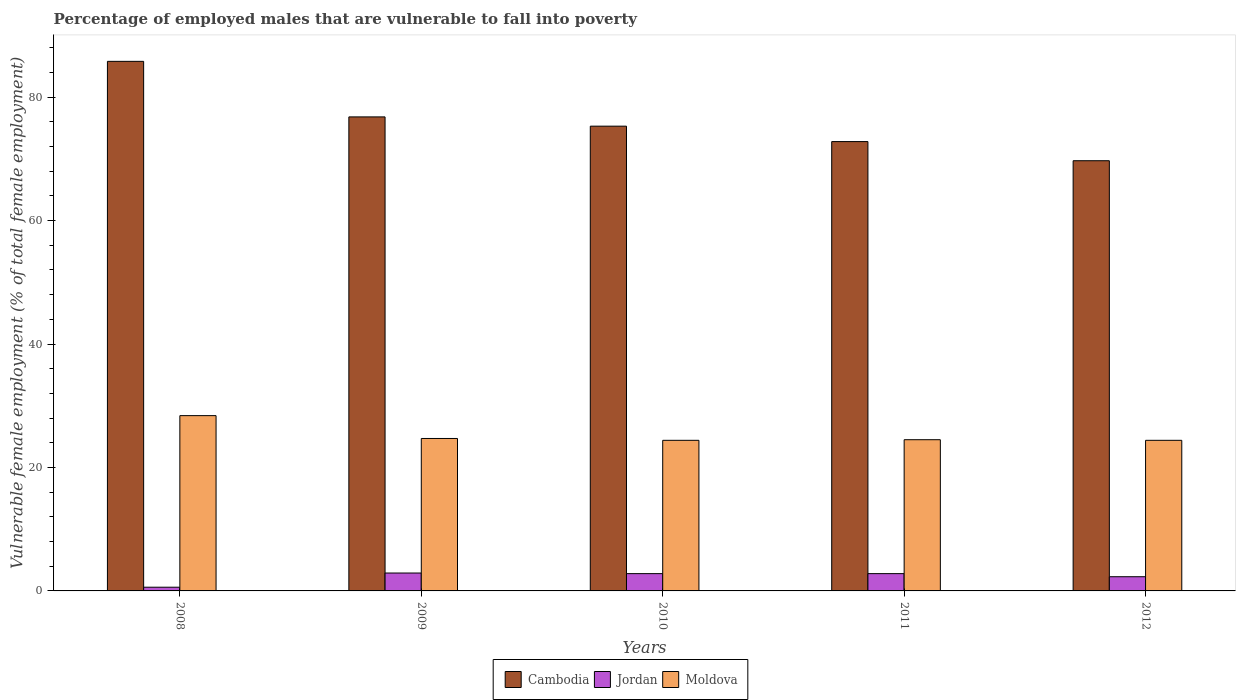How many groups of bars are there?
Offer a very short reply. 5. Are the number of bars per tick equal to the number of legend labels?
Provide a succinct answer. Yes. How many bars are there on the 5th tick from the right?
Offer a very short reply. 3. What is the label of the 3rd group of bars from the left?
Provide a succinct answer. 2010. Across all years, what is the maximum percentage of employed males who are vulnerable to fall into poverty in Moldova?
Your answer should be compact. 28.4. Across all years, what is the minimum percentage of employed males who are vulnerable to fall into poverty in Cambodia?
Your answer should be compact. 69.7. In which year was the percentage of employed males who are vulnerable to fall into poverty in Jordan maximum?
Ensure brevity in your answer.  2009. In which year was the percentage of employed males who are vulnerable to fall into poverty in Jordan minimum?
Offer a very short reply. 2008. What is the total percentage of employed males who are vulnerable to fall into poverty in Moldova in the graph?
Your response must be concise. 126.4. What is the difference between the percentage of employed males who are vulnerable to fall into poverty in Moldova in 2008 and the percentage of employed males who are vulnerable to fall into poverty in Jordan in 2012?
Give a very brief answer. 26.1. What is the average percentage of employed males who are vulnerable to fall into poverty in Cambodia per year?
Give a very brief answer. 76.08. In the year 2009, what is the difference between the percentage of employed males who are vulnerable to fall into poverty in Cambodia and percentage of employed males who are vulnerable to fall into poverty in Jordan?
Make the answer very short. 73.9. In how many years, is the percentage of employed males who are vulnerable to fall into poverty in Moldova greater than 32 %?
Make the answer very short. 0. What is the ratio of the percentage of employed males who are vulnerable to fall into poverty in Cambodia in 2009 to that in 2012?
Your response must be concise. 1.1. What is the difference between the highest and the second highest percentage of employed males who are vulnerable to fall into poverty in Jordan?
Keep it short and to the point. 0.1. What is the difference between the highest and the lowest percentage of employed males who are vulnerable to fall into poverty in Cambodia?
Your response must be concise. 16.1. In how many years, is the percentage of employed males who are vulnerable to fall into poverty in Cambodia greater than the average percentage of employed males who are vulnerable to fall into poverty in Cambodia taken over all years?
Your answer should be compact. 2. What does the 3rd bar from the left in 2008 represents?
Your answer should be compact. Moldova. What does the 3rd bar from the right in 2012 represents?
Offer a terse response. Cambodia. Are all the bars in the graph horizontal?
Make the answer very short. No. Are the values on the major ticks of Y-axis written in scientific E-notation?
Your response must be concise. No. Does the graph contain grids?
Make the answer very short. No. How many legend labels are there?
Provide a succinct answer. 3. What is the title of the graph?
Make the answer very short. Percentage of employed males that are vulnerable to fall into poverty. Does "St. Vincent and the Grenadines" appear as one of the legend labels in the graph?
Offer a very short reply. No. What is the label or title of the X-axis?
Ensure brevity in your answer.  Years. What is the label or title of the Y-axis?
Provide a short and direct response. Vulnerable female employment (% of total female employment). What is the Vulnerable female employment (% of total female employment) in Cambodia in 2008?
Give a very brief answer. 85.8. What is the Vulnerable female employment (% of total female employment) in Jordan in 2008?
Provide a short and direct response. 0.6. What is the Vulnerable female employment (% of total female employment) of Moldova in 2008?
Ensure brevity in your answer.  28.4. What is the Vulnerable female employment (% of total female employment) in Cambodia in 2009?
Give a very brief answer. 76.8. What is the Vulnerable female employment (% of total female employment) in Jordan in 2009?
Provide a succinct answer. 2.9. What is the Vulnerable female employment (% of total female employment) in Moldova in 2009?
Give a very brief answer. 24.7. What is the Vulnerable female employment (% of total female employment) in Cambodia in 2010?
Provide a succinct answer. 75.3. What is the Vulnerable female employment (% of total female employment) in Jordan in 2010?
Ensure brevity in your answer.  2.8. What is the Vulnerable female employment (% of total female employment) of Moldova in 2010?
Offer a very short reply. 24.4. What is the Vulnerable female employment (% of total female employment) in Cambodia in 2011?
Offer a very short reply. 72.8. What is the Vulnerable female employment (% of total female employment) of Jordan in 2011?
Your answer should be compact. 2.8. What is the Vulnerable female employment (% of total female employment) of Moldova in 2011?
Offer a terse response. 24.5. What is the Vulnerable female employment (% of total female employment) of Cambodia in 2012?
Give a very brief answer. 69.7. What is the Vulnerable female employment (% of total female employment) in Jordan in 2012?
Give a very brief answer. 2.3. What is the Vulnerable female employment (% of total female employment) of Moldova in 2012?
Your response must be concise. 24.4. Across all years, what is the maximum Vulnerable female employment (% of total female employment) of Cambodia?
Your answer should be very brief. 85.8. Across all years, what is the maximum Vulnerable female employment (% of total female employment) of Jordan?
Provide a succinct answer. 2.9. Across all years, what is the maximum Vulnerable female employment (% of total female employment) in Moldova?
Offer a terse response. 28.4. Across all years, what is the minimum Vulnerable female employment (% of total female employment) of Cambodia?
Ensure brevity in your answer.  69.7. Across all years, what is the minimum Vulnerable female employment (% of total female employment) of Jordan?
Your answer should be compact. 0.6. Across all years, what is the minimum Vulnerable female employment (% of total female employment) of Moldova?
Ensure brevity in your answer.  24.4. What is the total Vulnerable female employment (% of total female employment) of Cambodia in the graph?
Give a very brief answer. 380.4. What is the total Vulnerable female employment (% of total female employment) of Jordan in the graph?
Your answer should be very brief. 11.4. What is the total Vulnerable female employment (% of total female employment) of Moldova in the graph?
Make the answer very short. 126.4. What is the difference between the Vulnerable female employment (% of total female employment) in Cambodia in 2008 and that in 2010?
Offer a terse response. 10.5. What is the difference between the Vulnerable female employment (% of total female employment) in Moldova in 2008 and that in 2010?
Your answer should be very brief. 4. What is the difference between the Vulnerable female employment (% of total female employment) in Cambodia in 2008 and that in 2011?
Offer a very short reply. 13. What is the difference between the Vulnerable female employment (% of total female employment) in Moldova in 2008 and that in 2011?
Your answer should be very brief. 3.9. What is the difference between the Vulnerable female employment (% of total female employment) of Cambodia in 2008 and that in 2012?
Provide a short and direct response. 16.1. What is the difference between the Vulnerable female employment (% of total female employment) of Moldova in 2008 and that in 2012?
Keep it short and to the point. 4. What is the difference between the Vulnerable female employment (% of total female employment) of Cambodia in 2009 and that in 2010?
Your answer should be compact. 1.5. What is the difference between the Vulnerable female employment (% of total female employment) in Moldova in 2009 and that in 2010?
Your answer should be very brief. 0.3. What is the difference between the Vulnerable female employment (% of total female employment) of Cambodia in 2009 and that in 2011?
Provide a succinct answer. 4. What is the difference between the Vulnerable female employment (% of total female employment) of Jordan in 2009 and that in 2011?
Give a very brief answer. 0.1. What is the difference between the Vulnerable female employment (% of total female employment) in Cambodia in 2009 and that in 2012?
Keep it short and to the point. 7.1. What is the difference between the Vulnerable female employment (% of total female employment) in Jordan in 2009 and that in 2012?
Keep it short and to the point. 0.6. What is the difference between the Vulnerable female employment (% of total female employment) of Moldova in 2009 and that in 2012?
Your answer should be very brief. 0.3. What is the difference between the Vulnerable female employment (% of total female employment) in Jordan in 2010 and that in 2011?
Provide a succinct answer. 0. What is the difference between the Vulnerable female employment (% of total female employment) in Moldova in 2010 and that in 2011?
Provide a succinct answer. -0.1. What is the difference between the Vulnerable female employment (% of total female employment) in Moldova in 2010 and that in 2012?
Provide a short and direct response. 0. What is the difference between the Vulnerable female employment (% of total female employment) in Cambodia in 2011 and that in 2012?
Keep it short and to the point. 3.1. What is the difference between the Vulnerable female employment (% of total female employment) of Jordan in 2011 and that in 2012?
Keep it short and to the point. 0.5. What is the difference between the Vulnerable female employment (% of total female employment) of Cambodia in 2008 and the Vulnerable female employment (% of total female employment) of Jordan in 2009?
Offer a terse response. 82.9. What is the difference between the Vulnerable female employment (% of total female employment) of Cambodia in 2008 and the Vulnerable female employment (% of total female employment) of Moldova in 2009?
Your answer should be very brief. 61.1. What is the difference between the Vulnerable female employment (% of total female employment) of Jordan in 2008 and the Vulnerable female employment (% of total female employment) of Moldova in 2009?
Provide a short and direct response. -24.1. What is the difference between the Vulnerable female employment (% of total female employment) in Cambodia in 2008 and the Vulnerable female employment (% of total female employment) in Moldova in 2010?
Make the answer very short. 61.4. What is the difference between the Vulnerable female employment (% of total female employment) of Jordan in 2008 and the Vulnerable female employment (% of total female employment) of Moldova in 2010?
Make the answer very short. -23.8. What is the difference between the Vulnerable female employment (% of total female employment) in Cambodia in 2008 and the Vulnerable female employment (% of total female employment) in Jordan in 2011?
Your answer should be compact. 83. What is the difference between the Vulnerable female employment (% of total female employment) of Cambodia in 2008 and the Vulnerable female employment (% of total female employment) of Moldova in 2011?
Provide a short and direct response. 61.3. What is the difference between the Vulnerable female employment (% of total female employment) in Jordan in 2008 and the Vulnerable female employment (% of total female employment) in Moldova in 2011?
Offer a terse response. -23.9. What is the difference between the Vulnerable female employment (% of total female employment) in Cambodia in 2008 and the Vulnerable female employment (% of total female employment) in Jordan in 2012?
Offer a very short reply. 83.5. What is the difference between the Vulnerable female employment (% of total female employment) in Cambodia in 2008 and the Vulnerable female employment (% of total female employment) in Moldova in 2012?
Give a very brief answer. 61.4. What is the difference between the Vulnerable female employment (% of total female employment) of Jordan in 2008 and the Vulnerable female employment (% of total female employment) of Moldova in 2012?
Your answer should be very brief. -23.8. What is the difference between the Vulnerable female employment (% of total female employment) in Cambodia in 2009 and the Vulnerable female employment (% of total female employment) in Jordan in 2010?
Offer a very short reply. 74. What is the difference between the Vulnerable female employment (% of total female employment) of Cambodia in 2009 and the Vulnerable female employment (% of total female employment) of Moldova in 2010?
Keep it short and to the point. 52.4. What is the difference between the Vulnerable female employment (% of total female employment) of Jordan in 2009 and the Vulnerable female employment (% of total female employment) of Moldova in 2010?
Offer a very short reply. -21.5. What is the difference between the Vulnerable female employment (% of total female employment) of Cambodia in 2009 and the Vulnerable female employment (% of total female employment) of Jordan in 2011?
Offer a terse response. 74. What is the difference between the Vulnerable female employment (% of total female employment) in Cambodia in 2009 and the Vulnerable female employment (% of total female employment) in Moldova in 2011?
Offer a terse response. 52.3. What is the difference between the Vulnerable female employment (% of total female employment) of Jordan in 2009 and the Vulnerable female employment (% of total female employment) of Moldova in 2011?
Give a very brief answer. -21.6. What is the difference between the Vulnerable female employment (% of total female employment) in Cambodia in 2009 and the Vulnerable female employment (% of total female employment) in Jordan in 2012?
Offer a terse response. 74.5. What is the difference between the Vulnerable female employment (% of total female employment) in Cambodia in 2009 and the Vulnerable female employment (% of total female employment) in Moldova in 2012?
Provide a short and direct response. 52.4. What is the difference between the Vulnerable female employment (% of total female employment) in Jordan in 2009 and the Vulnerable female employment (% of total female employment) in Moldova in 2012?
Make the answer very short. -21.5. What is the difference between the Vulnerable female employment (% of total female employment) of Cambodia in 2010 and the Vulnerable female employment (% of total female employment) of Jordan in 2011?
Your answer should be compact. 72.5. What is the difference between the Vulnerable female employment (% of total female employment) in Cambodia in 2010 and the Vulnerable female employment (% of total female employment) in Moldova in 2011?
Keep it short and to the point. 50.8. What is the difference between the Vulnerable female employment (% of total female employment) of Jordan in 2010 and the Vulnerable female employment (% of total female employment) of Moldova in 2011?
Provide a short and direct response. -21.7. What is the difference between the Vulnerable female employment (% of total female employment) in Cambodia in 2010 and the Vulnerable female employment (% of total female employment) in Moldova in 2012?
Provide a succinct answer. 50.9. What is the difference between the Vulnerable female employment (% of total female employment) in Jordan in 2010 and the Vulnerable female employment (% of total female employment) in Moldova in 2012?
Your answer should be compact. -21.6. What is the difference between the Vulnerable female employment (% of total female employment) of Cambodia in 2011 and the Vulnerable female employment (% of total female employment) of Jordan in 2012?
Provide a short and direct response. 70.5. What is the difference between the Vulnerable female employment (% of total female employment) of Cambodia in 2011 and the Vulnerable female employment (% of total female employment) of Moldova in 2012?
Your response must be concise. 48.4. What is the difference between the Vulnerable female employment (% of total female employment) in Jordan in 2011 and the Vulnerable female employment (% of total female employment) in Moldova in 2012?
Make the answer very short. -21.6. What is the average Vulnerable female employment (% of total female employment) of Cambodia per year?
Your answer should be very brief. 76.08. What is the average Vulnerable female employment (% of total female employment) in Jordan per year?
Offer a terse response. 2.28. What is the average Vulnerable female employment (% of total female employment) in Moldova per year?
Your response must be concise. 25.28. In the year 2008, what is the difference between the Vulnerable female employment (% of total female employment) in Cambodia and Vulnerable female employment (% of total female employment) in Jordan?
Offer a very short reply. 85.2. In the year 2008, what is the difference between the Vulnerable female employment (% of total female employment) of Cambodia and Vulnerable female employment (% of total female employment) of Moldova?
Provide a succinct answer. 57.4. In the year 2008, what is the difference between the Vulnerable female employment (% of total female employment) of Jordan and Vulnerable female employment (% of total female employment) of Moldova?
Keep it short and to the point. -27.8. In the year 2009, what is the difference between the Vulnerable female employment (% of total female employment) of Cambodia and Vulnerable female employment (% of total female employment) of Jordan?
Keep it short and to the point. 73.9. In the year 2009, what is the difference between the Vulnerable female employment (% of total female employment) in Cambodia and Vulnerable female employment (% of total female employment) in Moldova?
Offer a very short reply. 52.1. In the year 2009, what is the difference between the Vulnerable female employment (% of total female employment) of Jordan and Vulnerable female employment (% of total female employment) of Moldova?
Your answer should be very brief. -21.8. In the year 2010, what is the difference between the Vulnerable female employment (% of total female employment) of Cambodia and Vulnerable female employment (% of total female employment) of Jordan?
Provide a short and direct response. 72.5. In the year 2010, what is the difference between the Vulnerable female employment (% of total female employment) in Cambodia and Vulnerable female employment (% of total female employment) in Moldova?
Make the answer very short. 50.9. In the year 2010, what is the difference between the Vulnerable female employment (% of total female employment) in Jordan and Vulnerable female employment (% of total female employment) in Moldova?
Provide a short and direct response. -21.6. In the year 2011, what is the difference between the Vulnerable female employment (% of total female employment) in Cambodia and Vulnerable female employment (% of total female employment) in Moldova?
Provide a short and direct response. 48.3. In the year 2011, what is the difference between the Vulnerable female employment (% of total female employment) in Jordan and Vulnerable female employment (% of total female employment) in Moldova?
Make the answer very short. -21.7. In the year 2012, what is the difference between the Vulnerable female employment (% of total female employment) of Cambodia and Vulnerable female employment (% of total female employment) of Jordan?
Offer a very short reply. 67.4. In the year 2012, what is the difference between the Vulnerable female employment (% of total female employment) of Cambodia and Vulnerable female employment (% of total female employment) of Moldova?
Your answer should be compact. 45.3. In the year 2012, what is the difference between the Vulnerable female employment (% of total female employment) in Jordan and Vulnerable female employment (% of total female employment) in Moldova?
Offer a terse response. -22.1. What is the ratio of the Vulnerable female employment (% of total female employment) of Cambodia in 2008 to that in 2009?
Keep it short and to the point. 1.12. What is the ratio of the Vulnerable female employment (% of total female employment) in Jordan in 2008 to that in 2009?
Offer a terse response. 0.21. What is the ratio of the Vulnerable female employment (% of total female employment) in Moldova in 2008 to that in 2009?
Offer a very short reply. 1.15. What is the ratio of the Vulnerable female employment (% of total female employment) of Cambodia in 2008 to that in 2010?
Your response must be concise. 1.14. What is the ratio of the Vulnerable female employment (% of total female employment) in Jordan in 2008 to that in 2010?
Your answer should be very brief. 0.21. What is the ratio of the Vulnerable female employment (% of total female employment) in Moldova in 2008 to that in 2010?
Your answer should be compact. 1.16. What is the ratio of the Vulnerable female employment (% of total female employment) of Cambodia in 2008 to that in 2011?
Provide a succinct answer. 1.18. What is the ratio of the Vulnerable female employment (% of total female employment) of Jordan in 2008 to that in 2011?
Your answer should be very brief. 0.21. What is the ratio of the Vulnerable female employment (% of total female employment) in Moldova in 2008 to that in 2011?
Give a very brief answer. 1.16. What is the ratio of the Vulnerable female employment (% of total female employment) of Cambodia in 2008 to that in 2012?
Ensure brevity in your answer.  1.23. What is the ratio of the Vulnerable female employment (% of total female employment) in Jordan in 2008 to that in 2012?
Make the answer very short. 0.26. What is the ratio of the Vulnerable female employment (% of total female employment) of Moldova in 2008 to that in 2012?
Your response must be concise. 1.16. What is the ratio of the Vulnerable female employment (% of total female employment) in Cambodia in 2009 to that in 2010?
Offer a terse response. 1.02. What is the ratio of the Vulnerable female employment (% of total female employment) in Jordan in 2009 to that in 2010?
Keep it short and to the point. 1.04. What is the ratio of the Vulnerable female employment (% of total female employment) in Moldova in 2009 to that in 2010?
Provide a short and direct response. 1.01. What is the ratio of the Vulnerable female employment (% of total female employment) in Cambodia in 2009 to that in 2011?
Ensure brevity in your answer.  1.05. What is the ratio of the Vulnerable female employment (% of total female employment) of Jordan in 2009 to that in 2011?
Provide a succinct answer. 1.04. What is the ratio of the Vulnerable female employment (% of total female employment) of Moldova in 2009 to that in 2011?
Make the answer very short. 1.01. What is the ratio of the Vulnerable female employment (% of total female employment) in Cambodia in 2009 to that in 2012?
Your answer should be very brief. 1.1. What is the ratio of the Vulnerable female employment (% of total female employment) in Jordan in 2009 to that in 2012?
Make the answer very short. 1.26. What is the ratio of the Vulnerable female employment (% of total female employment) in Moldova in 2009 to that in 2012?
Your answer should be very brief. 1.01. What is the ratio of the Vulnerable female employment (% of total female employment) in Cambodia in 2010 to that in 2011?
Offer a terse response. 1.03. What is the ratio of the Vulnerable female employment (% of total female employment) in Cambodia in 2010 to that in 2012?
Ensure brevity in your answer.  1.08. What is the ratio of the Vulnerable female employment (% of total female employment) in Jordan in 2010 to that in 2012?
Offer a terse response. 1.22. What is the ratio of the Vulnerable female employment (% of total female employment) in Cambodia in 2011 to that in 2012?
Provide a short and direct response. 1.04. What is the ratio of the Vulnerable female employment (% of total female employment) of Jordan in 2011 to that in 2012?
Provide a succinct answer. 1.22. What is the difference between the highest and the second highest Vulnerable female employment (% of total female employment) in Cambodia?
Give a very brief answer. 9. What is the difference between the highest and the second highest Vulnerable female employment (% of total female employment) in Jordan?
Offer a very short reply. 0.1. 